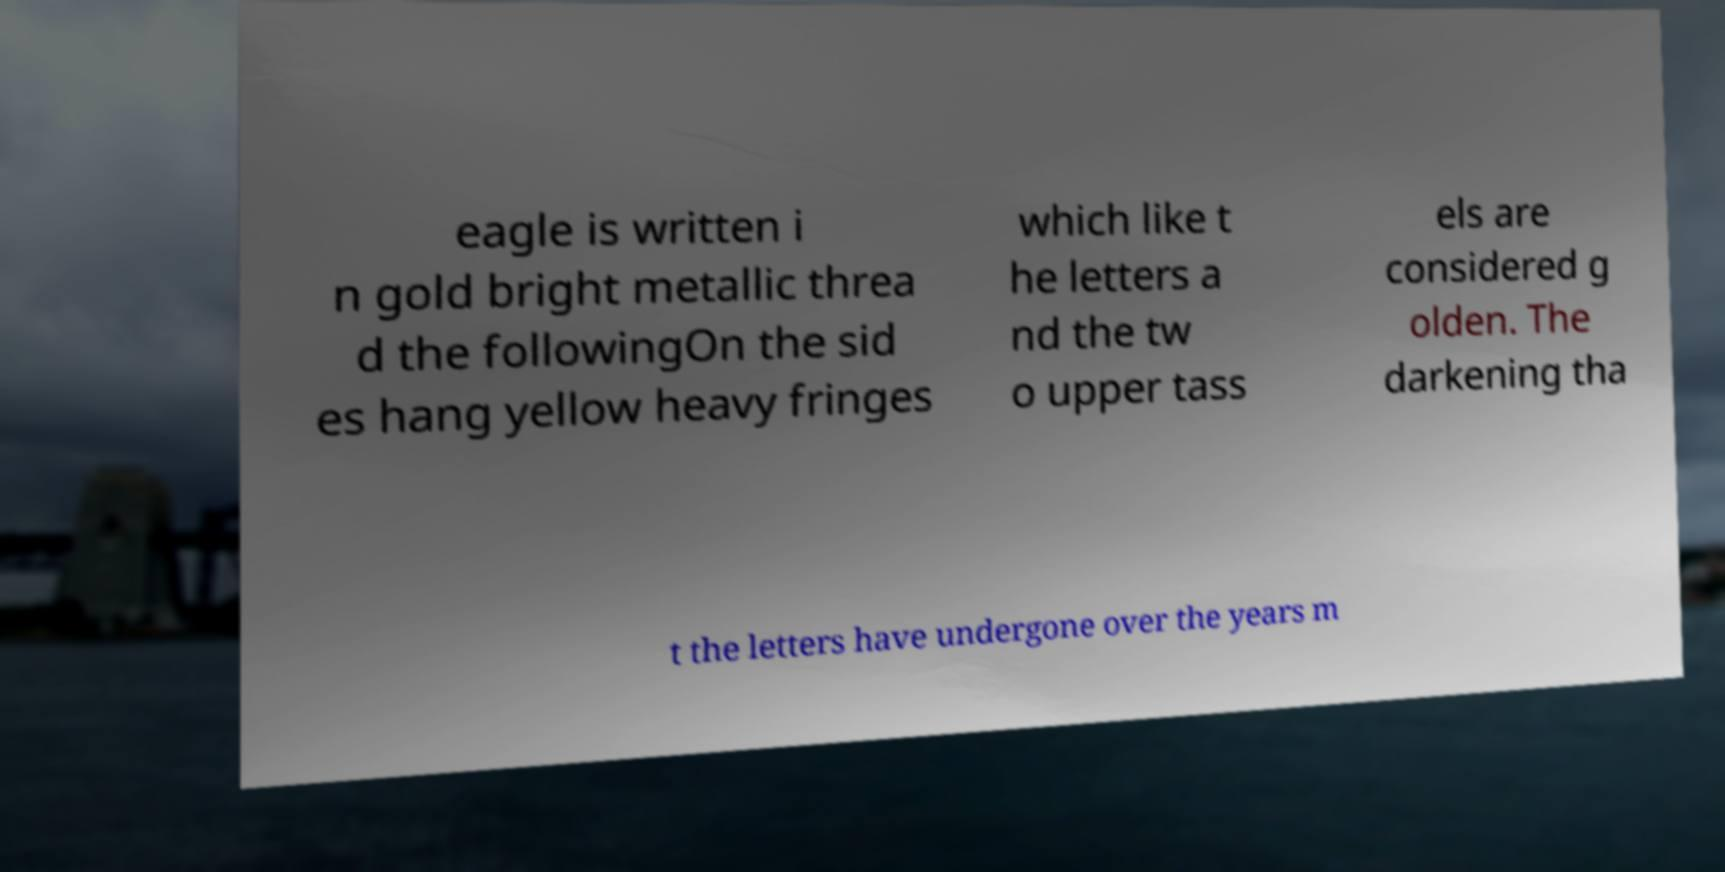What messages or text are displayed in this image? I need them in a readable, typed format. eagle is written i n gold bright metallic threa d the followingOn the sid es hang yellow heavy fringes which like t he letters a nd the tw o upper tass els are considered g olden. The darkening tha t the letters have undergone over the years m 